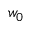<formula> <loc_0><loc_0><loc_500><loc_500>w _ { 0 }</formula> 